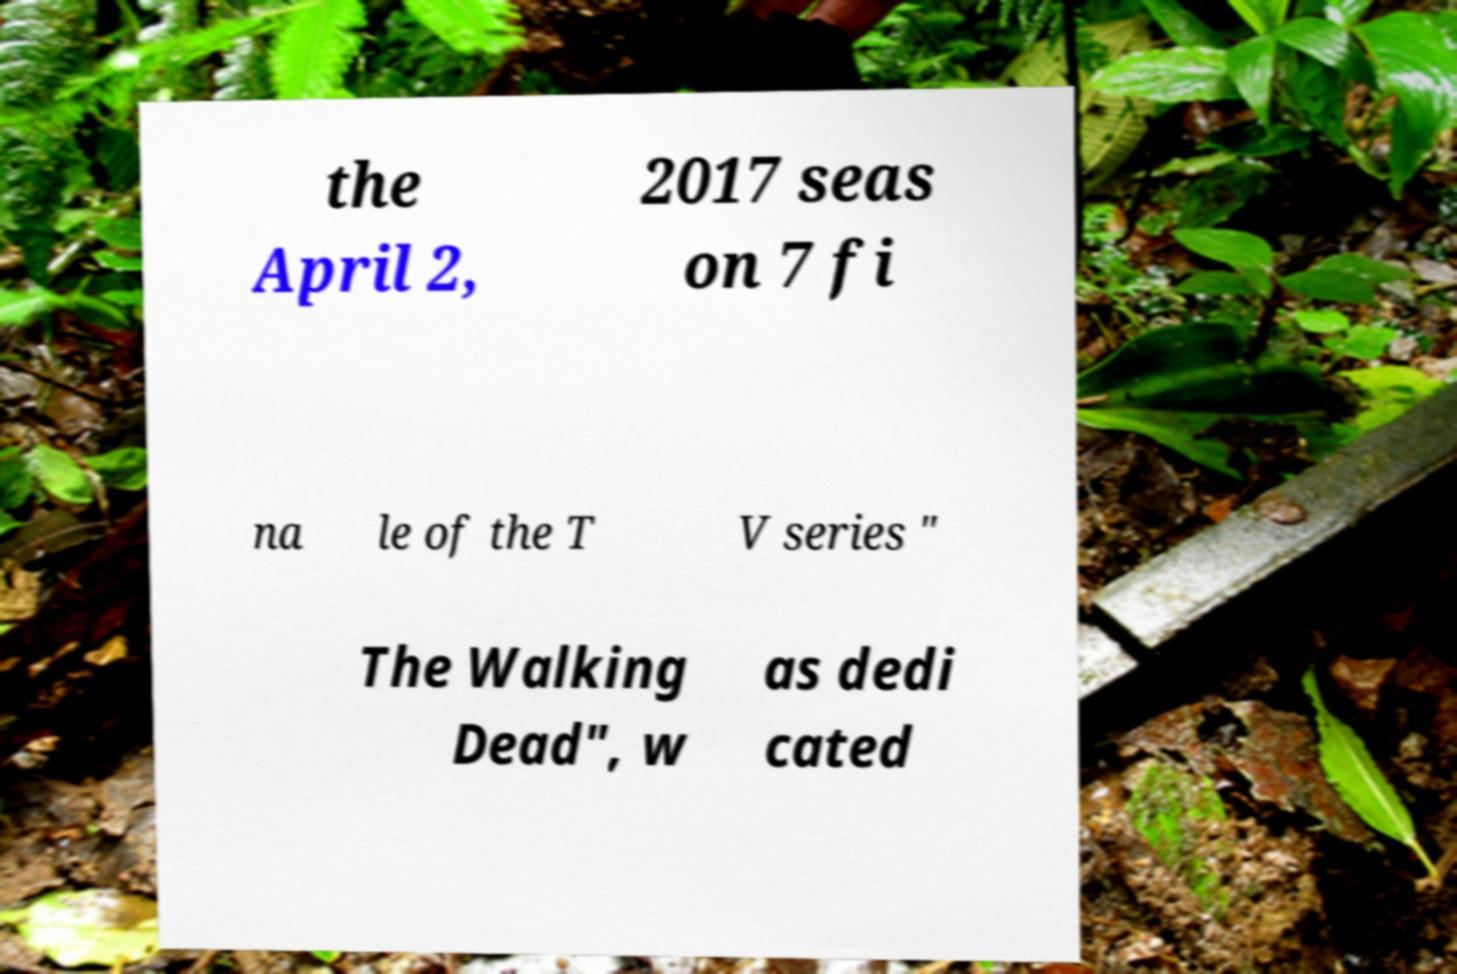Please read and relay the text visible in this image. What does it say? the April 2, 2017 seas on 7 fi na le of the T V series " The Walking Dead", w as dedi cated 